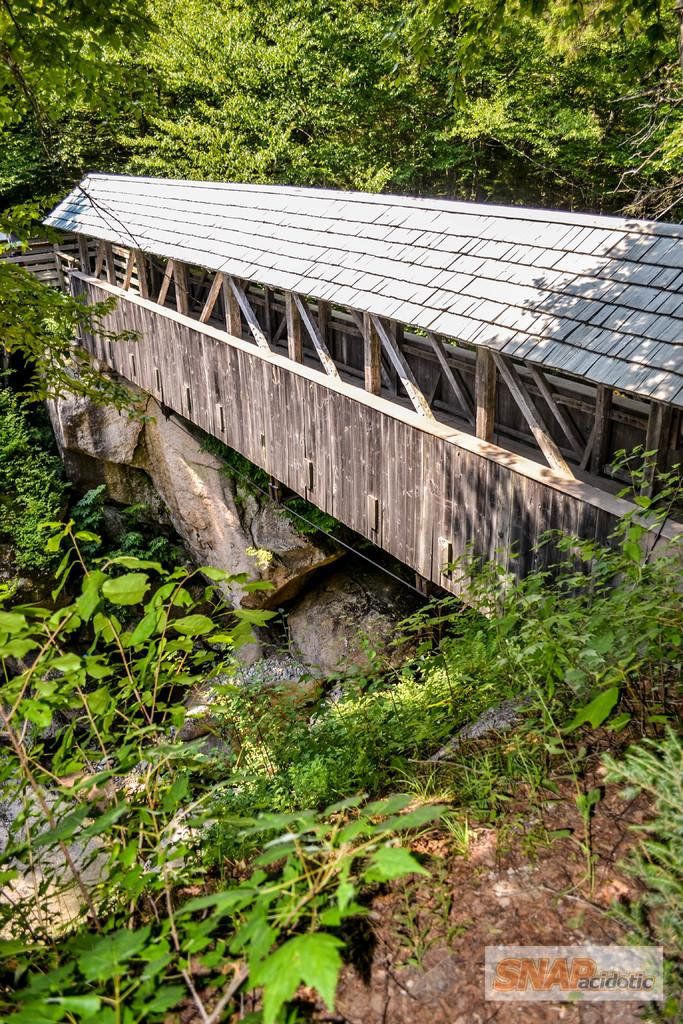What structure can be seen in the image? There is a bridge in the image. What material are the railings of the bridge made of? The bridge has wooden railings. What type of vegetation is present in the image? There are trees and plants in the image. What natural elements can be seen in the image? There are rocks in the image. Is there any text or marking in the image? Yes, there is a watermark in the right bottom corner of the image. What type of brick is used to build the fear in the image? There is no fear or brick present in the image; it features a bridge with wooden railings, trees, plants, rocks, and a watermark. 